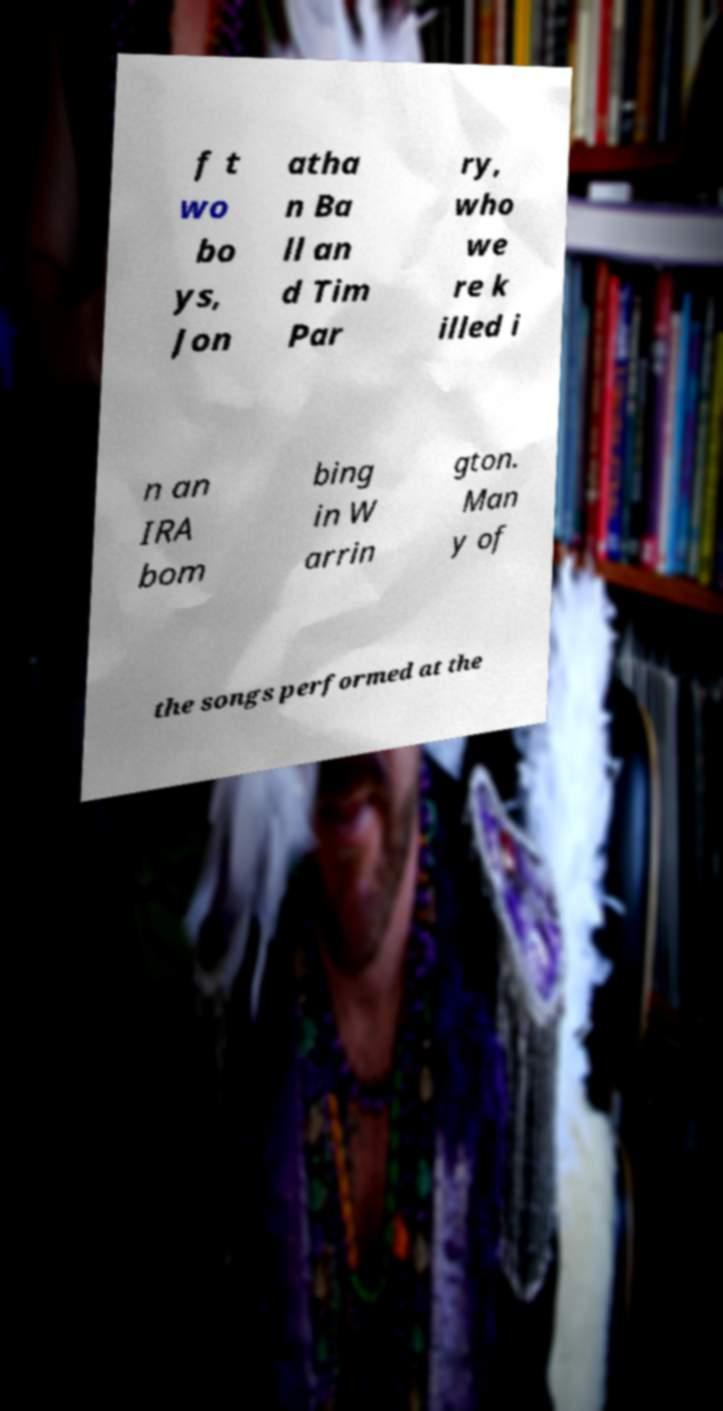Please read and relay the text visible in this image. What does it say? f t wo bo ys, Jon atha n Ba ll an d Tim Par ry, who we re k illed i n an IRA bom bing in W arrin gton. Man y of the songs performed at the 